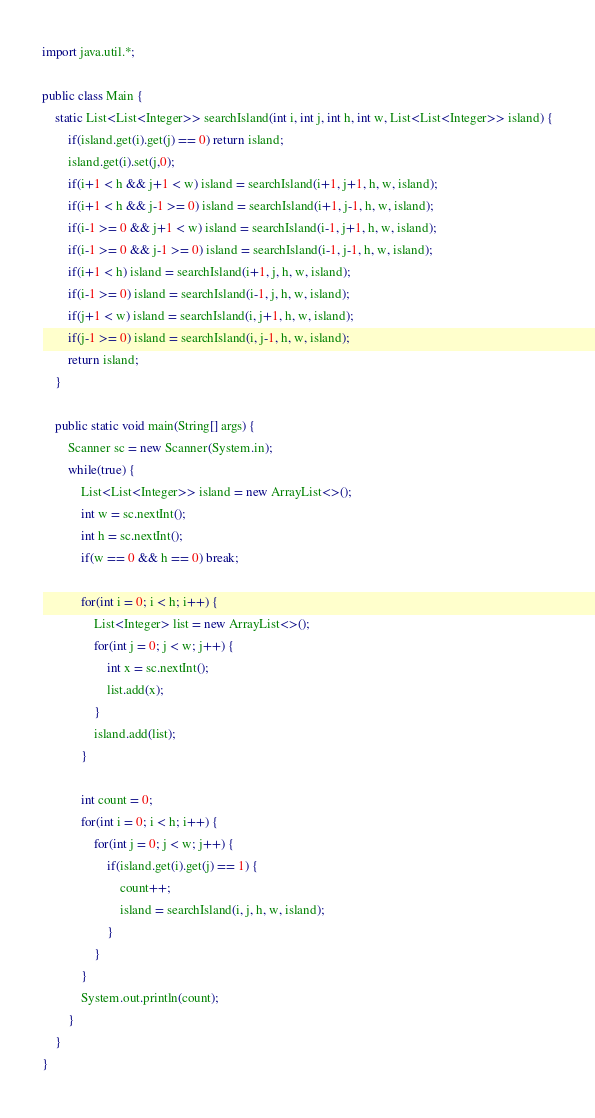Convert code to text. <code><loc_0><loc_0><loc_500><loc_500><_Java_>import java.util.*;

public class Main {
    static List<List<Integer>> searchIsland(int i, int j, int h, int w, List<List<Integer>> island) {
        if(island.get(i).get(j) == 0) return island;
        island.get(i).set(j,0);
        if(i+1 < h && j+1 < w) island = searchIsland(i+1, j+1, h, w, island);
        if(i+1 < h && j-1 >= 0) island = searchIsland(i+1, j-1, h, w, island);
        if(i-1 >= 0 && j+1 < w) island = searchIsland(i-1, j+1, h, w, island);
        if(i-1 >= 0 && j-1 >= 0) island = searchIsland(i-1, j-1, h, w, island);
        if(i+1 < h) island = searchIsland(i+1, j, h, w, island);
        if(i-1 >= 0) island = searchIsland(i-1, j, h, w, island);
        if(j+1 < w) island = searchIsland(i, j+1, h, w, island);
        if(j-1 >= 0) island = searchIsland(i, j-1, h, w, island);
        return island;
    }

    public static void main(String[] args) {
        Scanner sc = new Scanner(System.in);
        while(true) {
            List<List<Integer>> island = new ArrayList<>();
            int w = sc.nextInt();
            int h = sc.nextInt();
            if(w == 0 && h == 0) break;

            for(int i = 0; i < h; i++) {
                List<Integer> list = new ArrayList<>();
                for(int j = 0; j < w; j++) {
                    int x = sc.nextInt();
                    list.add(x);
                }
                island.add(list);
            }

            int count = 0;
            for(int i = 0; i < h; i++) {
                for(int j = 0; j < w; j++) {
                    if(island.get(i).get(j) == 1) {
                        count++;
                        island = searchIsland(i, j, h, w, island);
                    }
                }
            }
            System.out.println(count);
        }
    }
}
</code> 